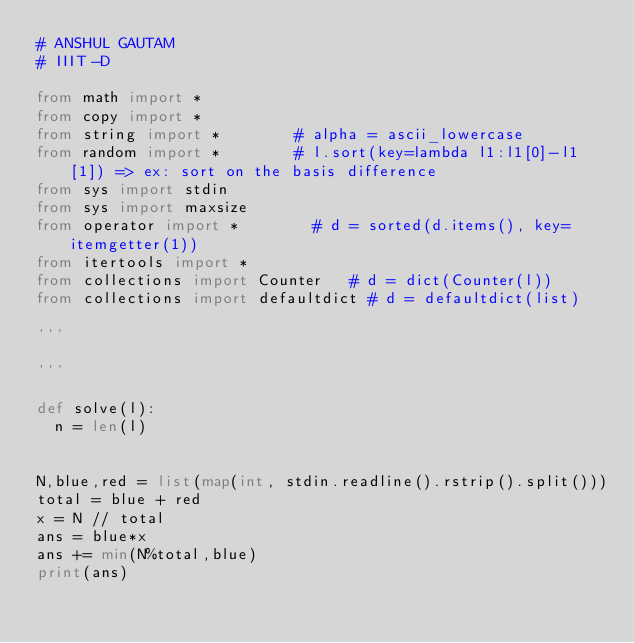<code> <loc_0><loc_0><loc_500><loc_500><_Python_># ANSHUL GAUTAM
# IIIT-D

from math import *
from copy import *
from string import *				# alpha = ascii_lowercase
from random import *				# l.sort(key=lambda l1:l1[0]-l1[1]) => ex: sort on the basis difference
from sys import stdin
from sys import maxsize
from operator import *				# d = sorted(d.items(), key=itemgetter(1))
from itertools import *
from collections import Counter		# d = dict(Counter(l))
from collections import defaultdict # d = defaultdict(list)

'''

'''

def solve(l):
	n = len(l)
	

N,blue,red = list(map(int, stdin.readline().rstrip().split()))
total = blue + red
x = N // total
ans = blue*x
ans += min(N%total,blue)
print(ans)</code> 